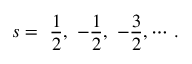Convert formula to latex. <formula><loc_0><loc_0><loc_500><loc_500>s = \frac { 1 } { 2 } , - \frac { 1 } { 2 } , - \frac { 3 } { 2 } , \cdots { \, } .</formula> 